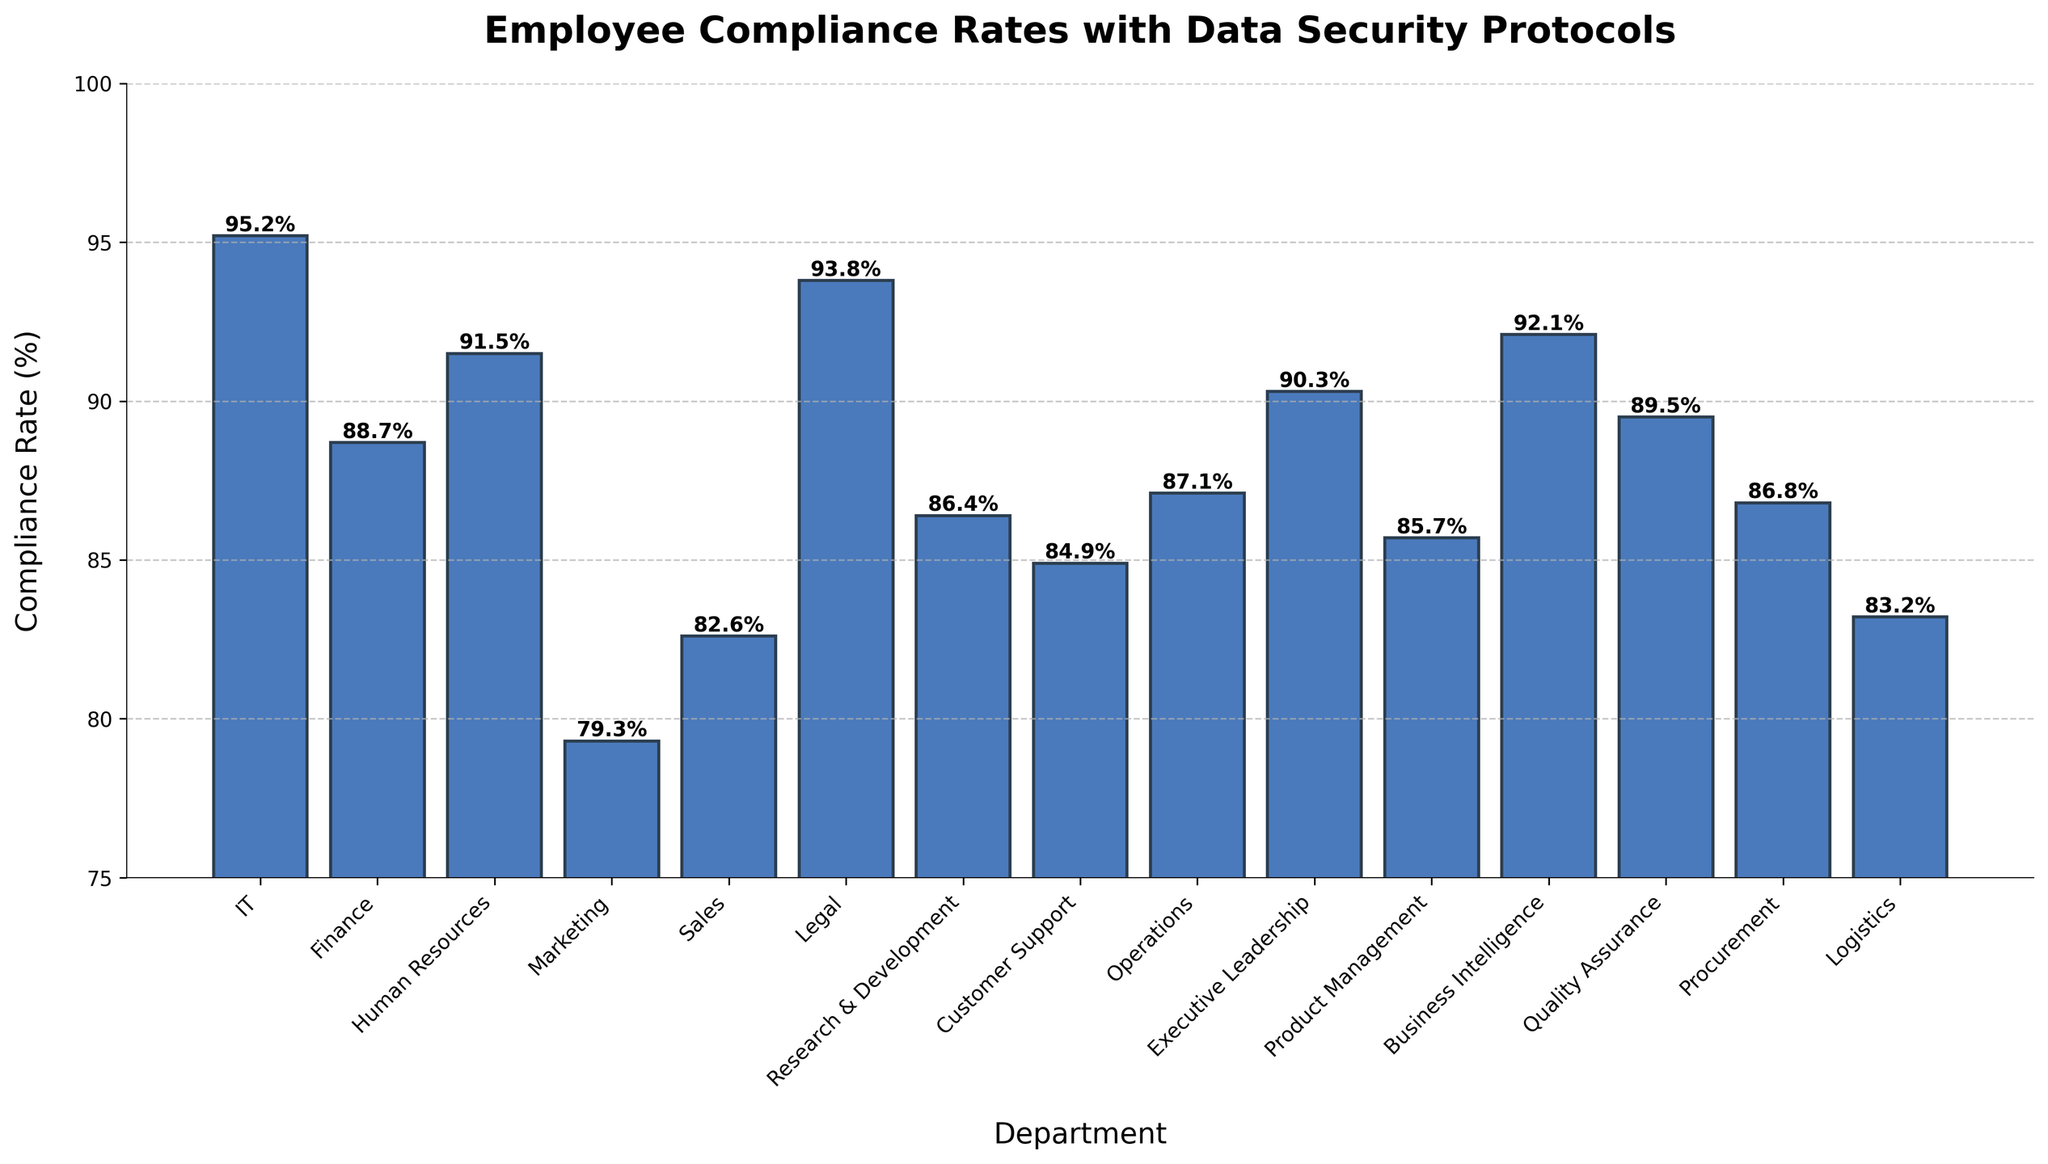Which department has the highest compliance rate? Find the bar with the highest value. The IT department has the highest bar at 95.2%.
Answer: IT Which department has the lowest compliance rate? Identify the bar with the lowest value. The Marketing department has the lowest bar at 79.3%.
Answer: Marketing What is the range of compliance rates across departments? Subtract the lowest compliance rate (Marketing, 79.3%) from the highest compliance rate (IT, 95.2%). The range is 95.2% - 79.3% = 15.9%.
Answer: 15.9% How many departments have a compliance rate above 90%? Count the bars with values above 90%. There are 6 departments: IT, Human Resources, Legal, Business Intelligence, Executive Leadership, and Quality Assurance.
Answer: 6 What is the average compliance rate for the departments? Sum all compliance rates and divide by the number of departments (15). The average is (95.2 + 88.7 + 91.5 + 79.3 + 82.6 + 93.8 + 86.4 + 84.9 + 87.1 + 90.3 + 85.7 + 92.1 + 89.5 + 86.8 + 83.2) / 15 = 87.9%.
Answer: 87.9% Which departments have compliance rates between 85% and 90% inclusive? Identify the bars that fall within the 85% to 90% range. Departments are Quality Assurance (89.5%), Procurement (86.8%), Operations (87.1%), Product Management (85.7%), Research & Development (86.4%), and Business Intelligence (92.1%, which needs to be excluded as it is above 90%).
Answer: Quality Assurance, Procurement, Operations, Product Management, Research & Development Compare the compliance rates of Sales and Customer Support. Which is higher? Locate the bars for Sales (82.6%) and Customer Support (84.9%). Customer Support has a higher compliance rate.
Answer: Customer Support What is the combined compliance rate of Finance and Legal departments? Add the compliance rates of Finance (88.7%) and Legal (93.8%). The combined rate is 88.7% + 93.8% = 182.5%.
Answer: 182.5% How much higher is the compliance rate in the Executive Leadership department compared to the Marketing department? Subtract the compliance rate of Marketing (79.3%) from that of Executive Leadership (90.3%). The difference is 90.3% - 79.3% = 11%.
Answer: 11% What is the median compliance rate? Arrange the compliance rates in ascending order and find the middle value. The ordered rates are: 79.3, 82.6, 83.2, 84.9, 85.7, 86.4, 86.8, 87.1, 88.7, 89.5, 90.3, 91.5, 92.1, 93.8, 95.2. The middle value (8th value) is 87.1%.
Answer: 87.1% 